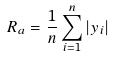Convert formula to latex. <formula><loc_0><loc_0><loc_500><loc_500>R _ { a } = \frac { 1 } { n } \sum _ { i = 1 } ^ { n } | y _ { i } |</formula> 